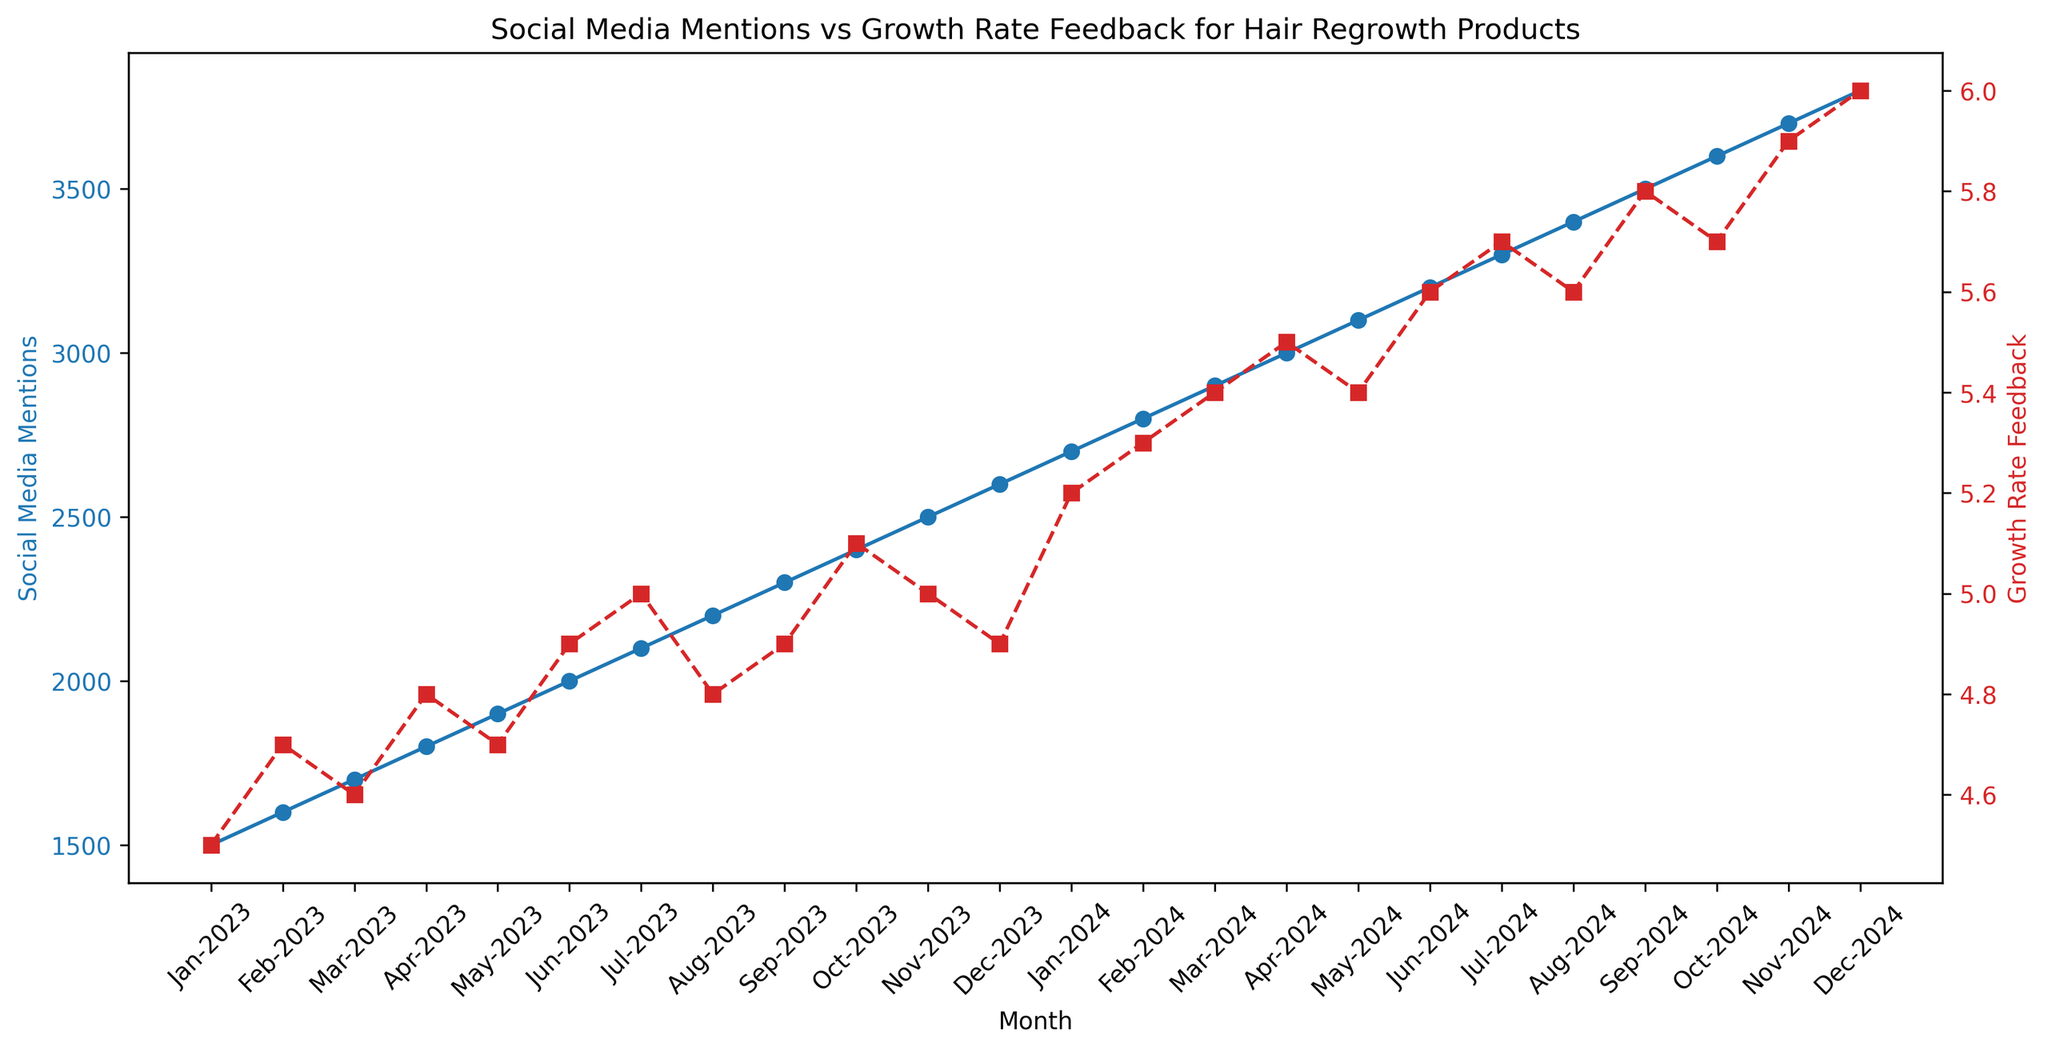What's the trend in Social Media Mentions from Jan-2023 to Dec-2024? The Social Media Mentions show a consistent upward trend from Jan-2023 to Dec-2024, starting at 1500 mentions in Jan-2023 and reaching 3800 mentions by Dec-2024.
Answer: Consistent upward trend What is the difference in Growth Rate Feedback between Jan-2023 and Dec-2024? The Growth Rate Feedback in Jan-2023 is 4.5, while in Dec-2024 it is 6.0. The difference is 6.0 - 4.5.
Answer: 1.5 Which month shows the highest Social Media Mentions and what is the corresponding Growth Rate Feedback for that month? Dec-2024 shows the highest Social Media Mentions at 3800. The corresponding Growth Rate Feedback for Dec-2024 is 6.0.
Answer: Dec-2024, 6.0 Compare the Growth Rate Feedback in Jan-2023 and Jul-2024. Which month has a higher value and by how much? In Jan-2023, the Growth Rate Feedback is 4.5, and in Jul-2024, it is 5.7. Jul-2024 has a higher value by 5.7 - 4.5.
Answer: Jul-2024, 1.2 How do the Social Media Mentions and Growth Rate Feedback values change from May-2023 to May-2024? Social Media Mentions increase from 1900 in May-2023 to 3100 in May-2024, while Growth Rate Feedback increases from 4.7 to 5.4 during the same period.
Answer: Both increase In which months do the Growth Rate Feedback values plateau or remain constant? The Growth Rate Feedback values remain constant between Mar-2023 (4.6) and Apr-2023 (4.8), and between May-2024 (5.4) and Jun-2024 (5.6), as well as between Aug-2024 (5.6) and Sept-2024 (5.8).
Answer: Mar-Apr 2023, May-Jun 2024, Aug-Sept 2024 Find the average Social Media Mentions for the year 2023. The Social Media Mentions from Jan-2023 to Dec-2023 are 1500, 1600, 1700, 1800, 1900, 2000, 2100, 2200, 2300, 2400, 2500, and 2600. The sum is 24600, and there are 12 months, so the average is 24600 / 12.
Answer: 2050 Is there a month where Social Media Mentions do not increase from the previous month? No, there is no month where Social Media Mentions do not increase from the previous month. Each month shows an increase compared to the previous month.
Answer: No 